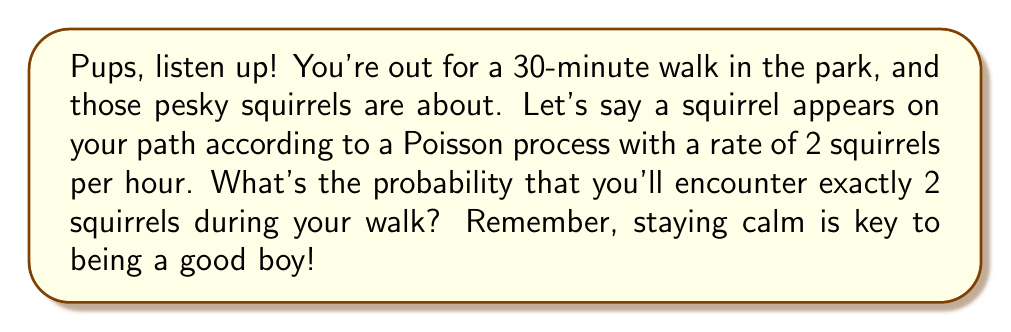Solve this math problem. Alright, young pups, let's break this down step by step:

1) First, we need to understand that this is a Poisson process. The number of squirrels we encounter in a fixed time interval follows a Poisson distribution.

2) We're given that the rate (λ) is 2 squirrels per hour. But our walk is only 30 minutes, which is half an hour. So we need to adjust our rate:

   $\lambda_{30min} = 2 \times \frac{1}{2} = 1$ squirrel per 30 minutes

3) Now, we want the probability of exactly 2 squirrels in this 30-minute period. We use the Poisson probability mass function:

   $$P(X = k) = \frac{e^{-\lambda}\lambda^k}{k!}$$

   Where $X$ is the number of events, $k$ is the specific number we're interested in (2 in this case), $e$ is Euler's number, and $\lambda$ is our adjusted rate.

4) Let's plug in our values:

   $$P(X = 2) = \frac{e^{-1} \cdot 1^2}{2!}$$

5) Simplify:
   $$P(X = 2) = \frac{e^{-1}}{2}$$

6) Calculate (rounded to 4 decimal places):
   $$P(X = 2) \approx 0.1839$$

So, pups, there's about an 18.39% chance of encountering exactly 2 squirrels on your walk. Remember, whether it's 0 or 10 squirrels, a good dog always stays on the path!
Answer: $\frac{e^{-1}}{2} \approx 0.1839$ 